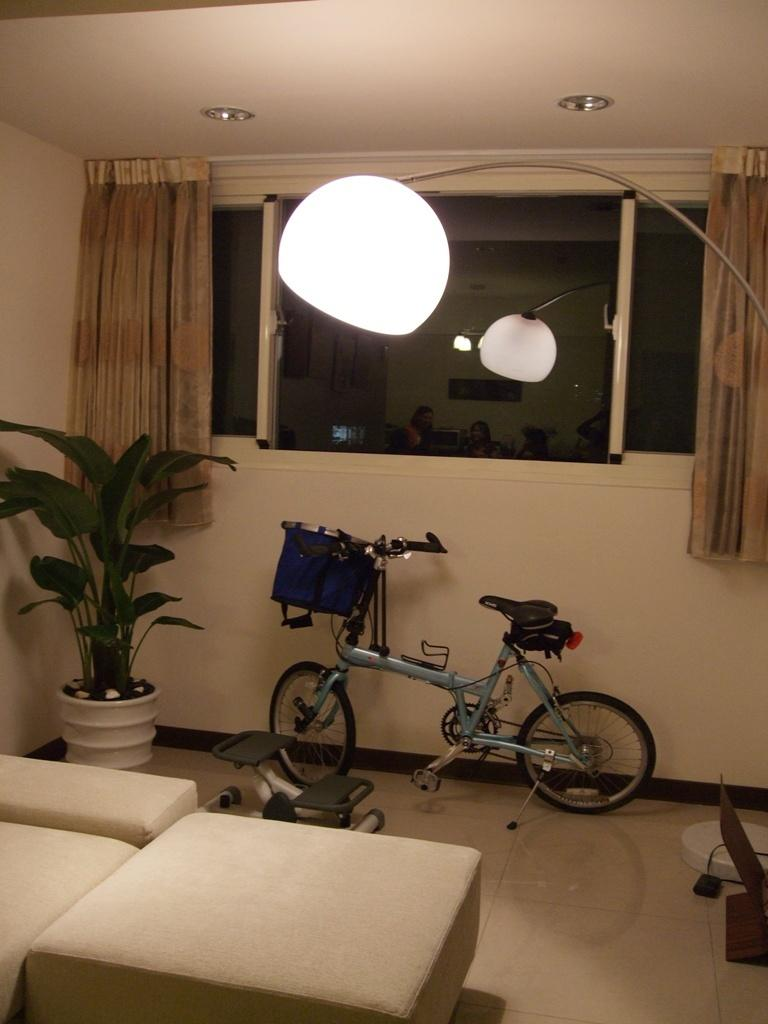Where is the setting of the image? The image is inside a room. What type of vegetation can be seen in the room? There is a plant in the room. What piece of furniture is present in the room? There is a couch in the room. What architectural feature is present in the room? There is a window with a curtain in the room. What source of light is present in the room? There is a lamp in the room. How many crows are sitting on the bicycle in the image? There are no crows present in the image; it only features a bicycle, plant, couch, window with a curtain, and lamp. 